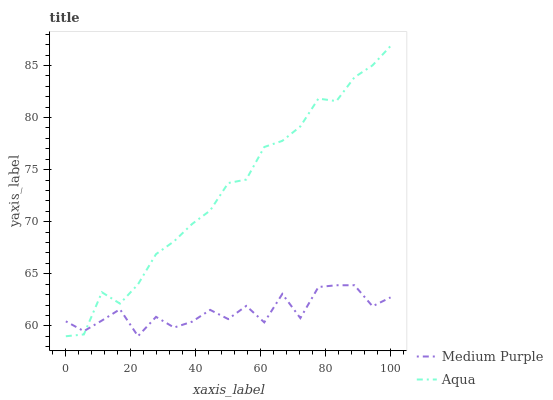Does Medium Purple have the minimum area under the curve?
Answer yes or no. Yes. Does Aqua have the maximum area under the curve?
Answer yes or no. Yes. Does Aqua have the minimum area under the curve?
Answer yes or no. No. Is Aqua the smoothest?
Answer yes or no. Yes. Is Medium Purple the roughest?
Answer yes or no. Yes. Is Aqua the roughest?
Answer yes or no. No. Does Aqua have the lowest value?
Answer yes or no. Yes. Does Aqua have the highest value?
Answer yes or no. Yes. Does Aqua intersect Medium Purple?
Answer yes or no. Yes. Is Aqua less than Medium Purple?
Answer yes or no. No. Is Aqua greater than Medium Purple?
Answer yes or no. No. 